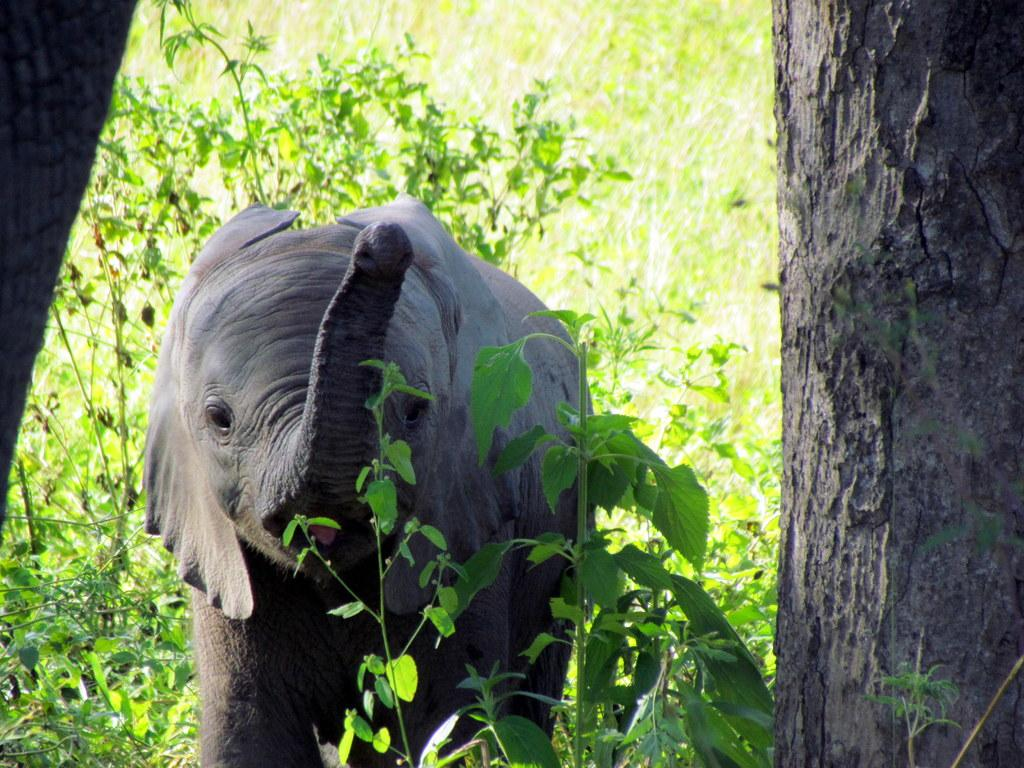What type of environment is depicted in the image? The image appears to depict a forest. What animal can be seen in the image? There is an elephant in the image. What feature of the forest is visible on both sides of the image? Tree trunks are visible on the right and left sides of the image. What can be seen in the distance in the image? There are many plants in the background of the image. What type of can is visible in the image? There is no can present in the image. What is the daughter of the elephant doing in the image? There is no daughter of the elephant depicted in the image. 